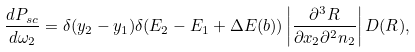<formula> <loc_0><loc_0><loc_500><loc_500>\frac { d P _ { s c } } { d \omega _ { 2 } } = \delta ( y _ { 2 } - y _ { 1 } ) \delta ( E _ { 2 } - E _ { 1 } + \Delta E ( b ) ) \left | \frac { \partial ^ { 3 } { R } } { \partial x _ { 2 } \partial ^ { 2 } { n } _ { 2 } } \right | D ( { R } ) ,</formula> 